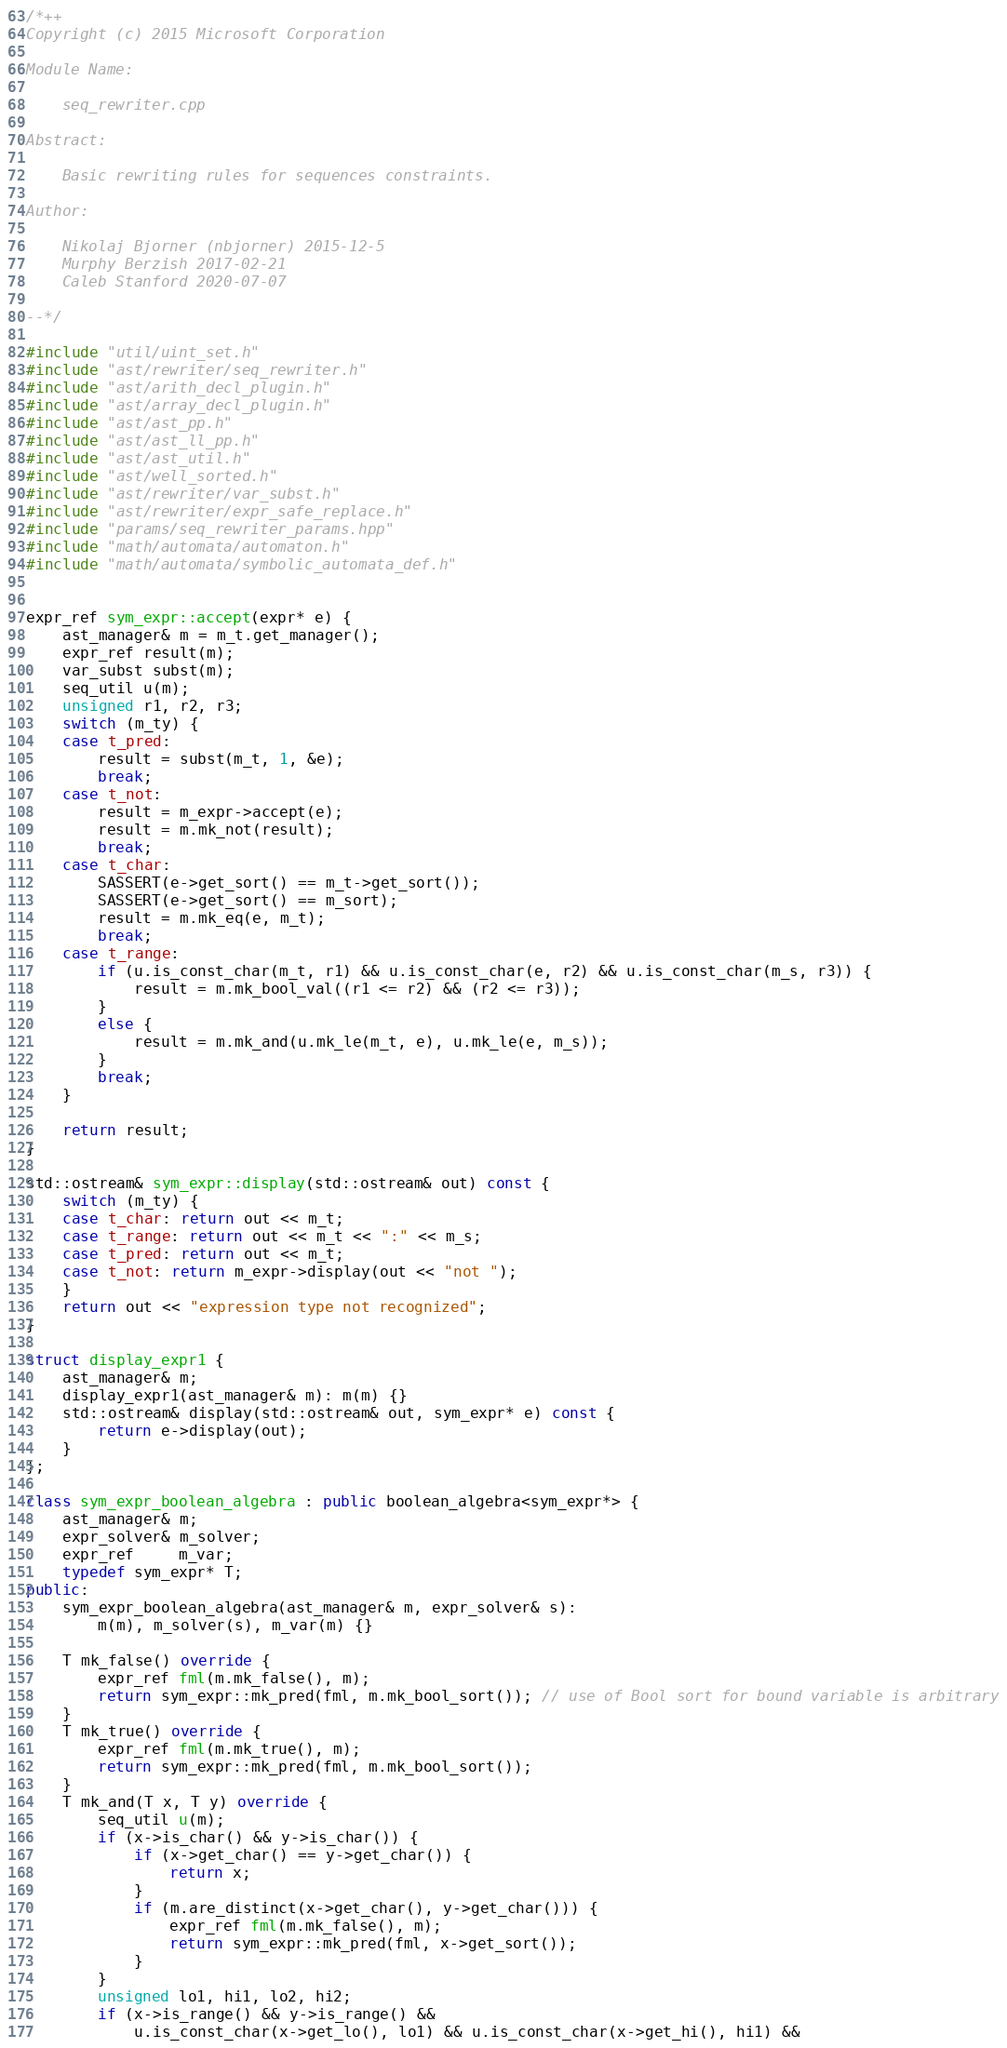Convert code to text. <code><loc_0><loc_0><loc_500><loc_500><_C++_>/*++
Copyright (c) 2015 Microsoft Corporation

Module Name:

    seq_rewriter.cpp

Abstract:

    Basic rewriting rules for sequences constraints.

Author:

    Nikolaj Bjorner (nbjorner) 2015-12-5
    Murphy Berzish 2017-02-21
    Caleb Stanford 2020-07-07

--*/

#include "util/uint_set.h"
#include "ast/rewriter/seq_rewriter.h"
#include "ast/arith_decl_plugin.h"
#include "ast/array_decl_plugin.h"
#include "ast/ast_pp.h"
#include "ast/ast_ll_pp.h"
#include "ast/ast_util.h"
#include "ast/well_sorted.h"
#include "ast/rewriter/var_subst.h"
#include "ast/rewriter/expr_safe_replace.h"
#include "params/seq_rewriter_params.hpp"
#include "math/automata/automaton.h"
#include "math/automata/symbolic_automata_def.h"


expr_ref sym_expr::accept(expr* e) {
    ast_manager& m = m_t.get_manager();
    expr_ref result(m);
    var_subst subst(m);
    seq_util u(m);
    unsigned r1, r2, r3;
    switch (m_ty) {
    case t_pred:         
        result = subst(m_t, 1, &e);
        break;    
    case t_not:
        result = m_expr->accept(e);
        result = m.mk_not(result);
        break;
    case t_char:
        SASSERT(e->get_sort() == m_t->get_sort());
        SASSERT(e->get_sort() == m_sort);
        result = m.mk_eq(e, m_t);
        break;
    case t_range: 
        if (u.is_const_char(m_t, r1) && u.is_const_char(e, r2) && u.is_const_char(m_s, r3)) {
            result = m.mk_bool_val((r1 <= r2) && (r2 <= r3));            
        }
        else {
            result = m.mk_and(u.mk_le(m_t, e), u.mk_le(e, m_s));
        }
        break;
    }
    
    return result;
}

std::ostream& sym_expr::display(std::ostream& out) const {
    switch (m_ty) {
    case t_char: return out << m_t;
    case t_range: return out << m_t << ":" << m_s;
    case t_pred: return out << m_t;
    case t_not: return m_expr->display(out << "not ");
    }
    return out << "expression type not recognized";
}

struct display_expr1 {
    ast_manager& m;
    display_expr1(ast_manager& m): m(m) {}
    std::ostream& display(std::ostream& out, sym_expr* e) const {
        return e->display(out);
    }
};

class sym_expr_boolean_algebra : public boolean_algebra<sym_expr*> {
    ast_manager& m;
    expr_solver& m_solver;
    expr_ref     m_var;
    typedef sym_expr* T;
public:
    sym_expr_boolean_algebra(ast_manager& m, expr_solver& s): 
        m(m), m_solver(s), m_var(m) {}

    T mk_false() override {
        expr_ref fml(m.mk_false(), m);
        return sym_expr::mk_pred(fml, m.mk_bool_sort()); // use of Bool sort for bound variable is arbitrary
    }
    T mk_true() override {
        expr_ref fml(m.mk_true(), m);
        return sym_expr::mk_pred(fml, m.mk_bool_sort());
    }
    T mk_and(T x, T y) override {
        seq_util u(m);
        if (x->is_char() && y->is_char()) {
            if (x->get_char() == y->get_char()) {
                return x;
            }
            if (m.are_distinct(x->get_char(), y->get_char())) {
                expr_ref fml(m.mk_false(), m);
                return sym_expr::mk_pred(fml, x->get_sort());
            }
        }
        unsigned lo1, hi1, lo2, hi2;
        if (x->is_range() && y->is_range() &&
            u.is_const_char(x->get_lo(), lo1) && u.is_const_char(x->get_hi(), hi1) &&</code> 